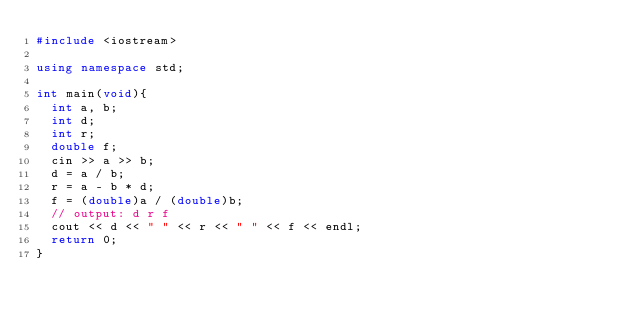<code> <loc_0><loc_0><loc_500><loc_500><_C++_>#include <iostream>

using namespace std;

int main(void){
  int a, b;
  int d;
  int r;
  double f;
  cin >> a >> b;
  d = a / b;
  r = a - b * d;
  f = (double)a / (double)b;
  // output: d r f
  cout << d << " " << r << " " << f << endl;
  return 0;
}
</code> 